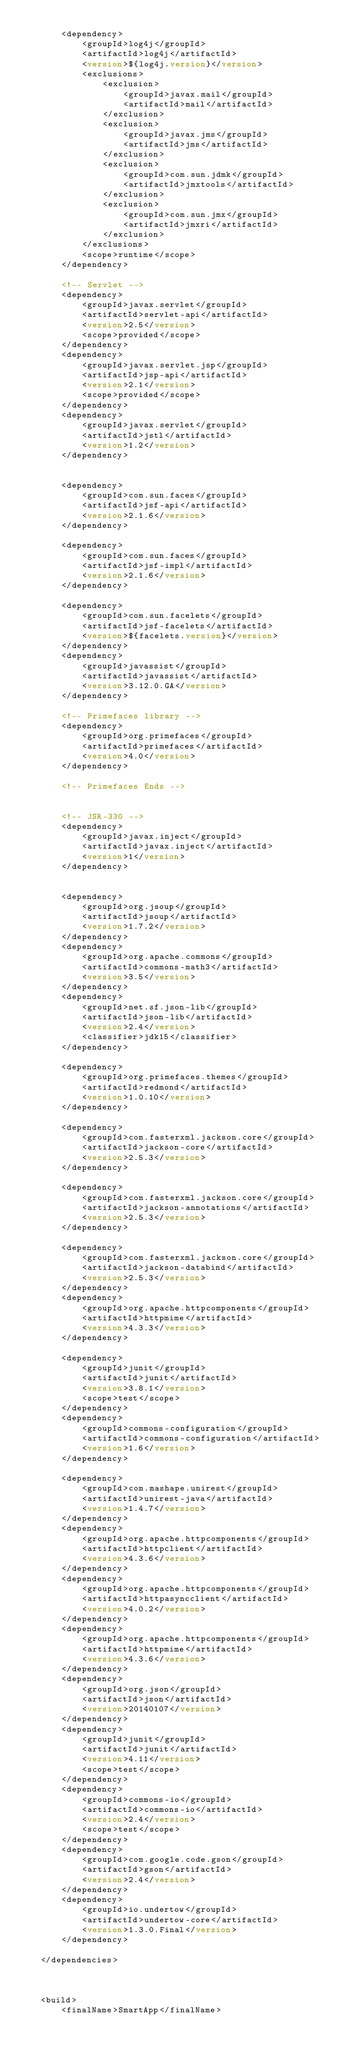<code> <loc_0><loc_0><loc_500><loc_500><_XML_>
		<dependency>
			<groupId>log4j</groupId>
			<artifactId>log4j</artifactId>
			<version>${log4j.version}</version>
			<exclusions>
				<exclusion>
					<groupId>javax.mail</groupId>
					<artifactId>mail</artifactId>
				</exclusion>
				<exclusion>
					<groupId>javax.jms</groupId>
					<artifactId>jms</artifactId>
				</exclusion>
				<exclusion>
					<groupId>com.sun.jdmk</groupId>
					<artifactId>jmxtools</artifactId>
				</exclusion>
				<exclusion>
					<groupId>com.sun.jmx</groupId>
					<artifactId>jmxri</artifactId>
				</exclusion>
			</exclusions>
			<scope>runtime</scope>
		</dependency>

		<!-- Servlet -->
		<dependency>
			<groupId>javax.servlet</groupId>
			<artifactId>servlet-api</artifactId>
			<version>2.5</version>
			<scope>provided</scope>
		</dependency>
		<dependency>
			<groupId>javax.servlet.jsp</groupId>
			<artifactId>jsp-api</artifactId>
			<version>2.1</version>
			<scope>provided</scope>
		</dependency>
		<dependency>
			<groupId>javax.servlet</groupId>
			<artifactId>jstl</artifactId>
			<version>1.2</version>
		</dependency>


		<dependency>
			<groupId>com.sun.faces</groupId>
			<artifactId>jsf-api</artifactId>
			<version>2.1.6</version>
		</dependency>

		<dependency>
			<groupId>com.sun.faces</groupId>
			<artifactId>jsf-impl</artifactId>
			<version>2.1.6</version>
		</dependency>

		<dependency>
			<groupId>com.sun.facelets</groupId>
			<artifactId>jsf-facelets</artifactId>
			<version>${facelets.version}</version>
		</dependency>
		<dependency>
			<groupId>javassist</groupId>
			<artifactId>javassist</artifactId>
			<version>3.12.0.GA</version>
		</dependency>

		<!-- Primefaces library -->
		<dependency>
			<groupId>org.primefaces</groupId>
			<artifactId>primefaces</artifactId>
			<version>4.0</version>
		</dependency>

		<!-- Primefaces Ends -->


		<!-- JSR-330 -->
		<dependency>
			<groupId>javax.inject</groupId>
			<artifactId>javax.inject</artifactId>
			<version>1</version>
		</dependency>


		<dependency>
			<groupId>org.jsoup</groupId>
			<artifactId>jsoup</artifactId>
			<version>1.7.2</version>
		</dependency>
		<dependency>
			<groupId>org.apache.commons</groupId>
			<artifactId>commons-math3</artifactId>
			<version>3.5</version>
		</dependency>
		<dependency>
			<groupId>net.sf.json-lib</groupId>
			<artifactId>json-lib</artifactId>
			<version>2.4</version>
			<classifier>jdk15</classifier>
		</dependency>

		<dependency>
			<groupId>org.primefaces.themes</groupId>
			<artifactId>redmond</artifactId>
			<version>1.0.10</version>
		</dependency>

		<dependency>
			<groupId>com.fasterxml.jackson.core</groupId>
			<artifactId>jackson-core</artifactId>
			<version>2.5.3</version>
		</dependency>

		<dependency>
			<groupId>com.fasterxml.jackson.core</groupId>
			<artifactId>jackson-annotations</artifactId>
			<version>2.5.3</version>
		</dependency>

		<dependency>
			<groupId>com.fasterxml.jackson.core</groupId>
			<artifactId>jackson-databind</artifactId>
			<version>2.5.3</version>
		</dependency>
		<dependency>
			<groupId>org.apache.httpcomponents</groupId>
			<artifactId>httpmime</artifactId>
			<version>4.3.3</version>
		</dependency>

		<dependency>
			<groupId>junit</groupId>
			<artifactId>junit</artifactId>
			<version>3.8.1</version>
			<scope>test</scope>
		</dependency>
		<dependency>
			<groupId>commons-configuration</groupId>
			<artifactId>commons-configuration</artifactId>
			<version>1.6</version>
		</dependency>

		<dependency>
			<groupId>com.mashape.unirest</groupId>
			<artifactId>unirest-java</artifactId>
			<version>1.4.7</version>
		</dependency>
		<dependency>
			<groupId>org.apache.httpcomponents</groupId>
			<artifactId>httpclient</artifactId>
			<version>4.3.6</version>
		</dependency>
		<dependency>
			<groupId>org.apache.httpcomponents</groupId>
			<artifactId>httpasyncclient</artifactId>
			<version>4.0.2</version>
		</dependency>
		<dependency>
			<groupId>org.apache.httpcomponents</groupId>
			<artifactId>httpmime</artifactId>
			<version>4.3.6</version>
		</dependency>
		<dependency>
			<groupId>org.json</groupId>
			<artifactId>json</artifactId>
			<version>20140107</version>
		</dependency>
		<dependency>
			<groupId>junit</groupId>
			<artifactId>junit</artifactId>
			<version>4.11</version>
			<scope>test</scope>
		</dependency>
		<dependency>
			<groupId>commons-io</groupId>
			<artifactId>commons-io</artifactId>
			<version>2.4</version>
			<scope>test</scope>
		</dependency>
		<dependency>
			<groupId>com.google.code.gson</groupId>
			<artifactId>gson</artifactId>
			<version>2.4</version>
		</dependency>
		<dependency>
			<groupId>io.undertow</groupId>
			<artifactId>undertow-core</artifactId>
			<version>1.3.0.Final</version>
		</dependency>

	</dependencies>



	<build>
		<finalName>SmartApp</finalName></code> 